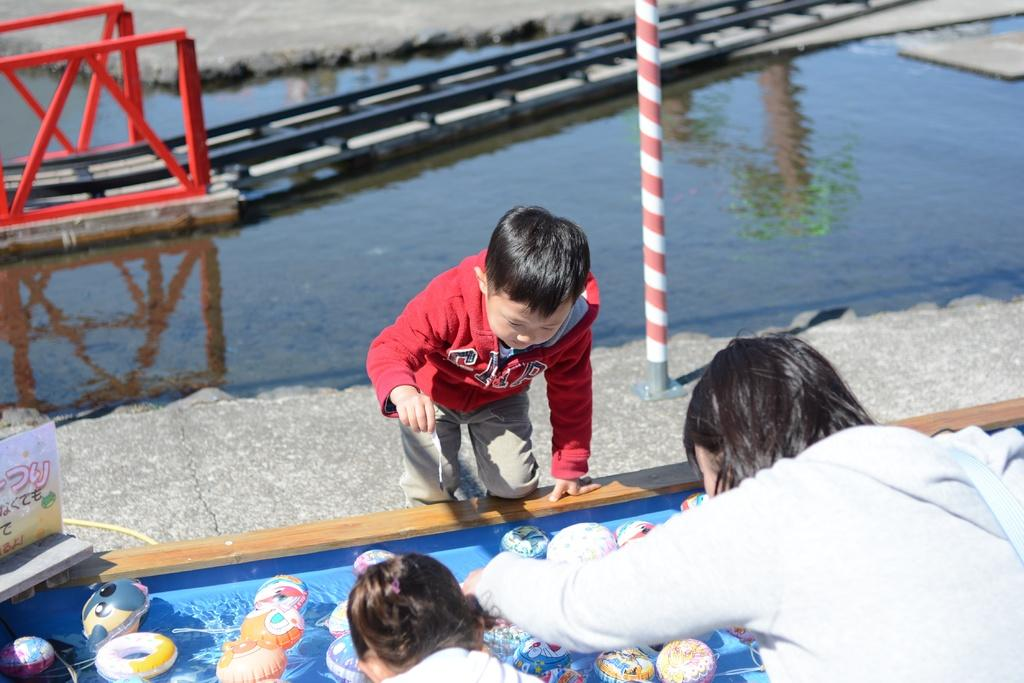Who is present in the foreground of the image? There are children and a man in the foreground of the image. What objects can be seen in front of the children and the man? It appears that there are toys in front of the children and the man. What is the pole used for in the image? The purpose of the pole is not specified in the image. What is the condition of the water visible in the image? The facts provided do not specify the condition of the water. What structure can be seen in the background of the image? There is a bridge in the background of the image. What type of agreement is being discussed by the children and the man in the image? There is no indication in the image that the children and the man are discussing any agreement. 